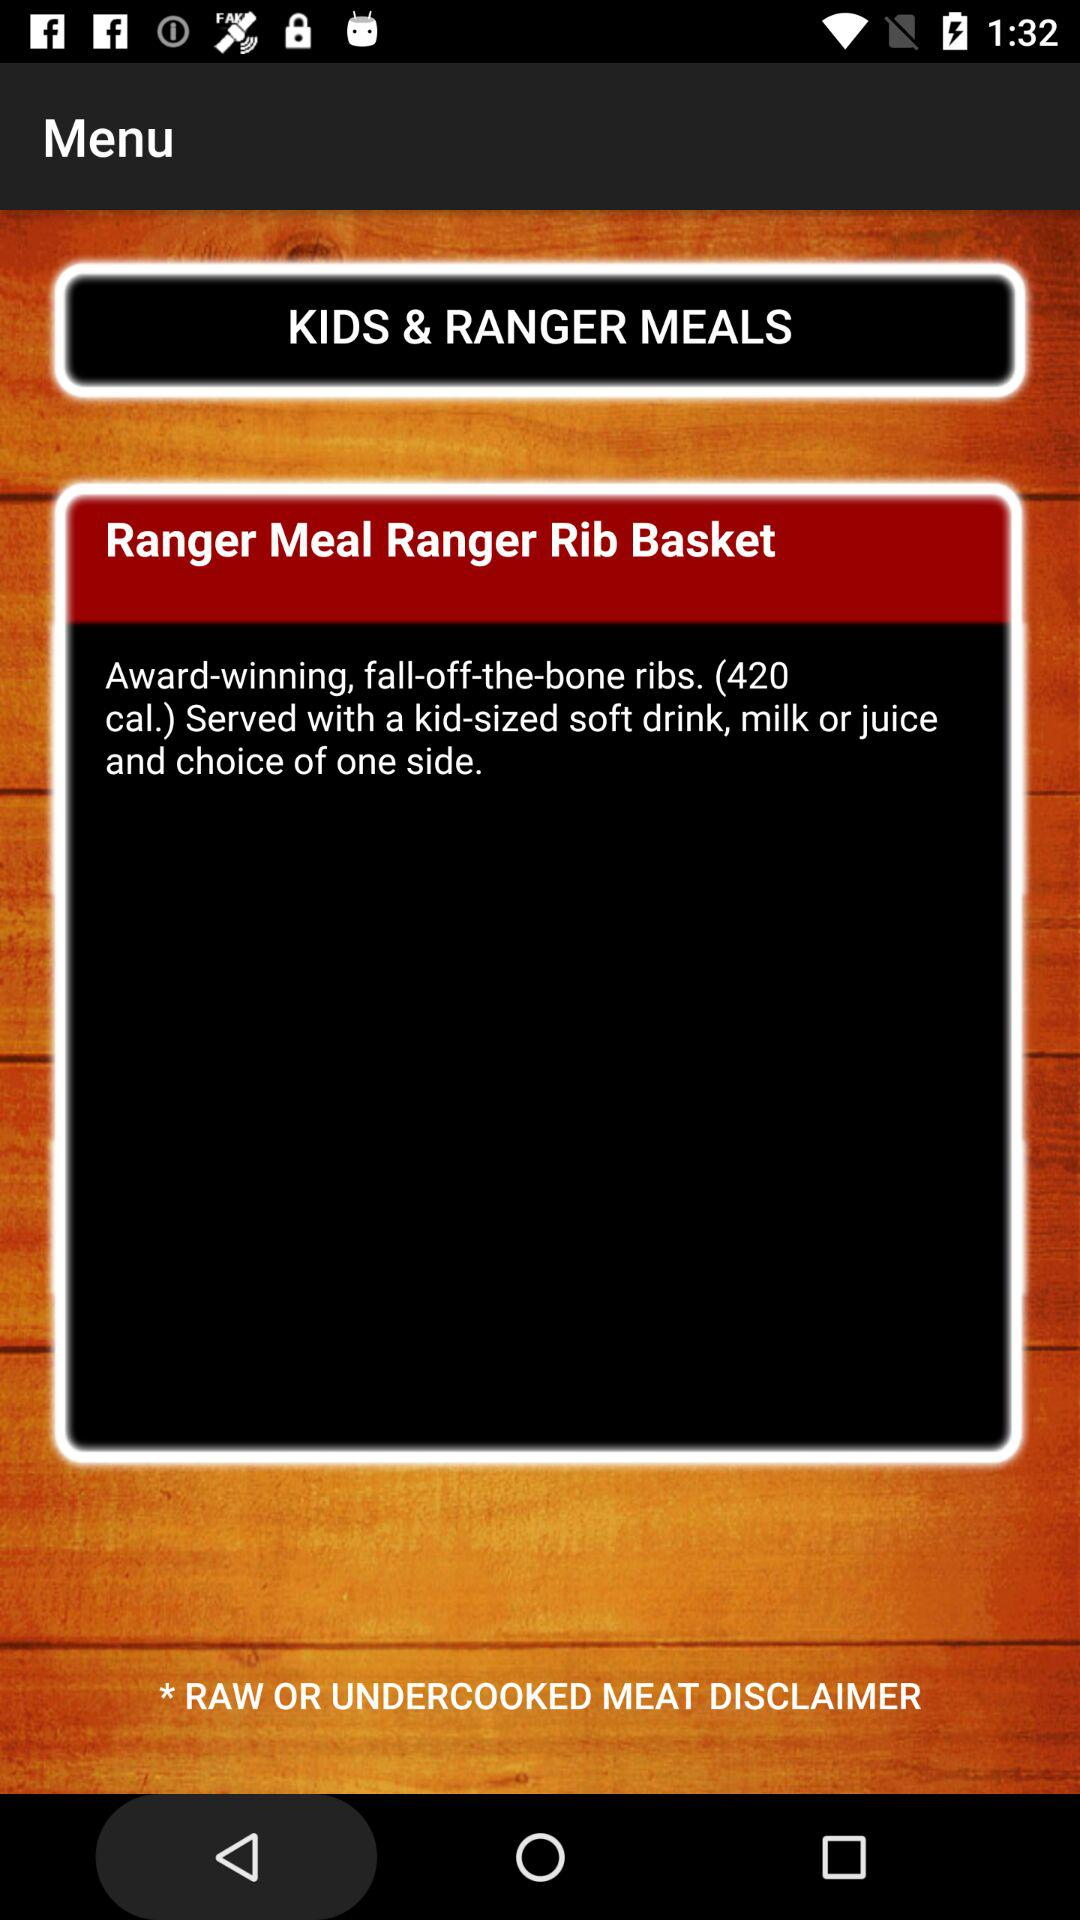How many calories are in fall-off-the-bone ribs? There are 420 calories. 